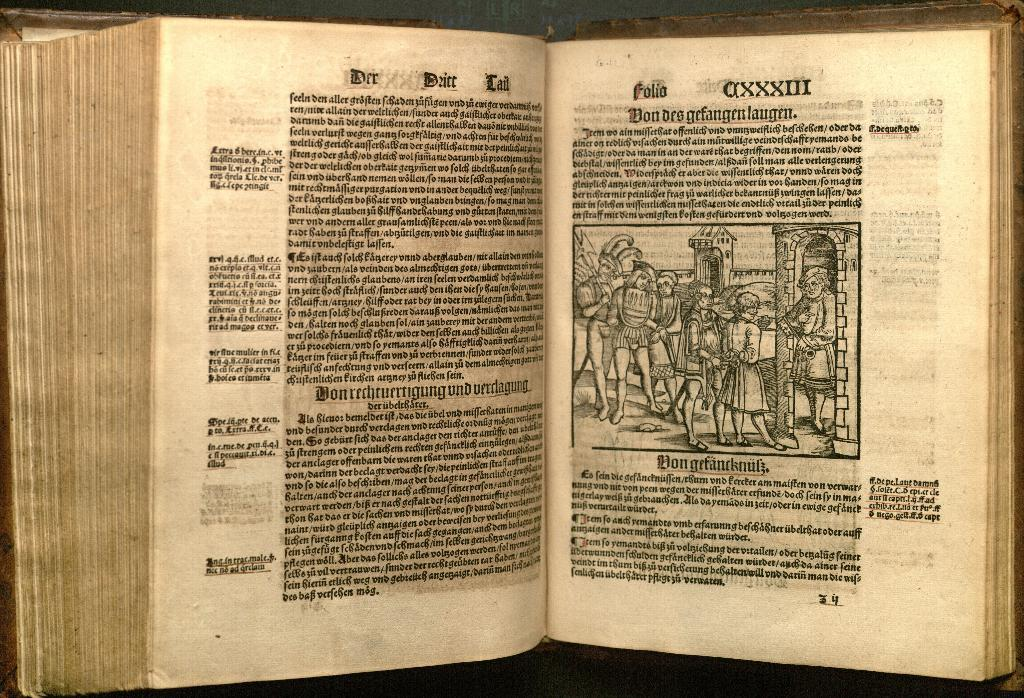Provide a one-sentence caption for the provided image. A photo of an ancient text of some kind that appears to be in ancient German or Italian. It appears to date to the 1st century. 